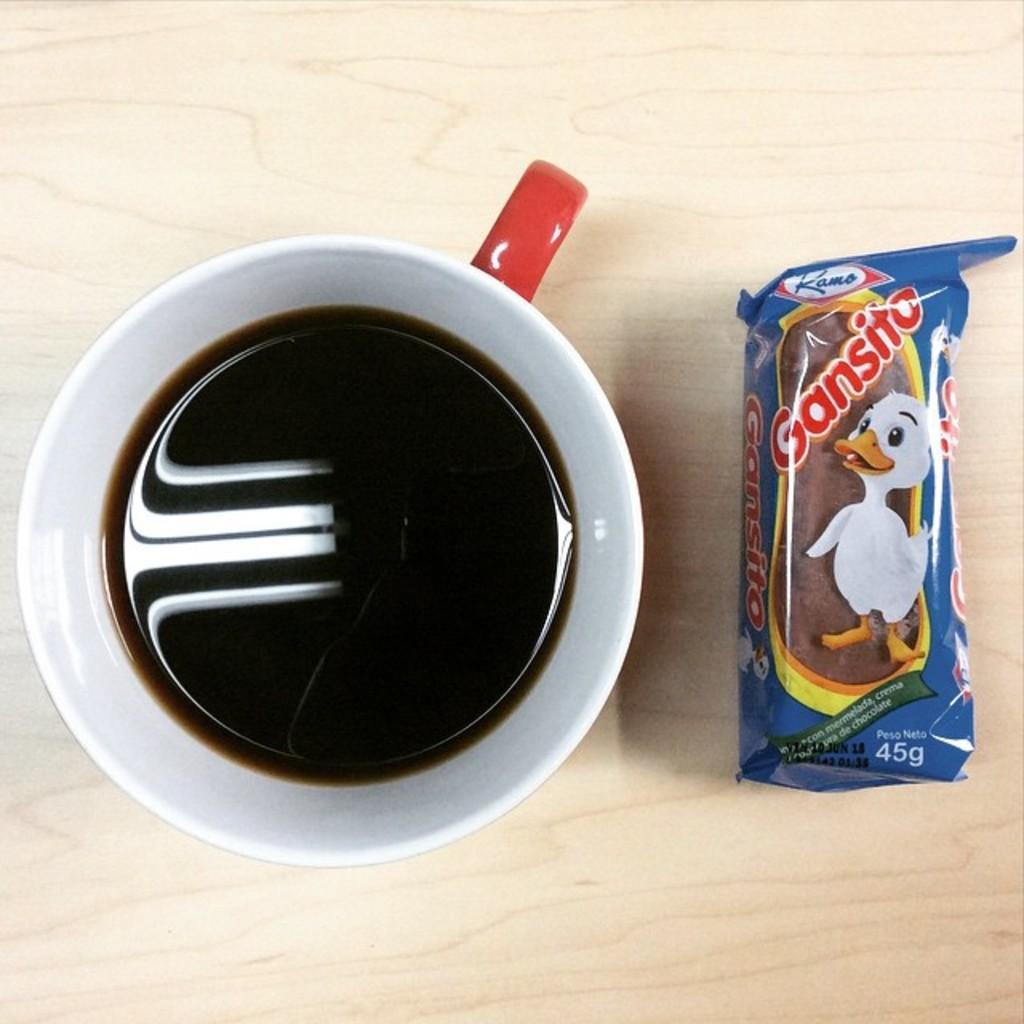In one or two sentences, can you explain what this image depicts? In this image, we can see a tea cup and a biscuit packet on the wooden surface. 